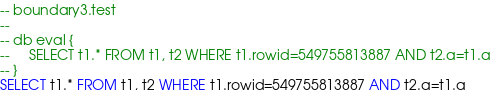Convert code to text. <code><loc_0><loc_0><loc_500><loc_500><_SQL_>-- boundary3.test
-- 
-- db eval {
--     SELECT t1.* FROM t1, t2 WHERE t1.rowid=549755813887 AND t2.a=t1.a
-- }
SELECT t1.* FROM t1, t2 WHERE t1.rowid=549755813887 AND t2.a=t1.a</code> 